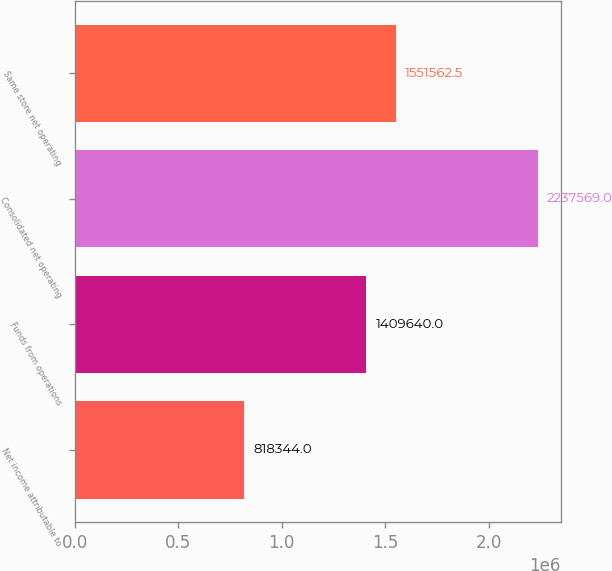Convert chart to OTSL. <chart><loc_0><loc_0><loc_500><loc_500><bar_chart><fcel>Net income attributable to<fcel>Funds from operations<fcel>Consolidated net operating<fcel>Same store net operating<nl><fcel>818344<fcel>1.40964e+06<fcel>2.23757e+06<fcel>1.55156e+06<nl></chart> 